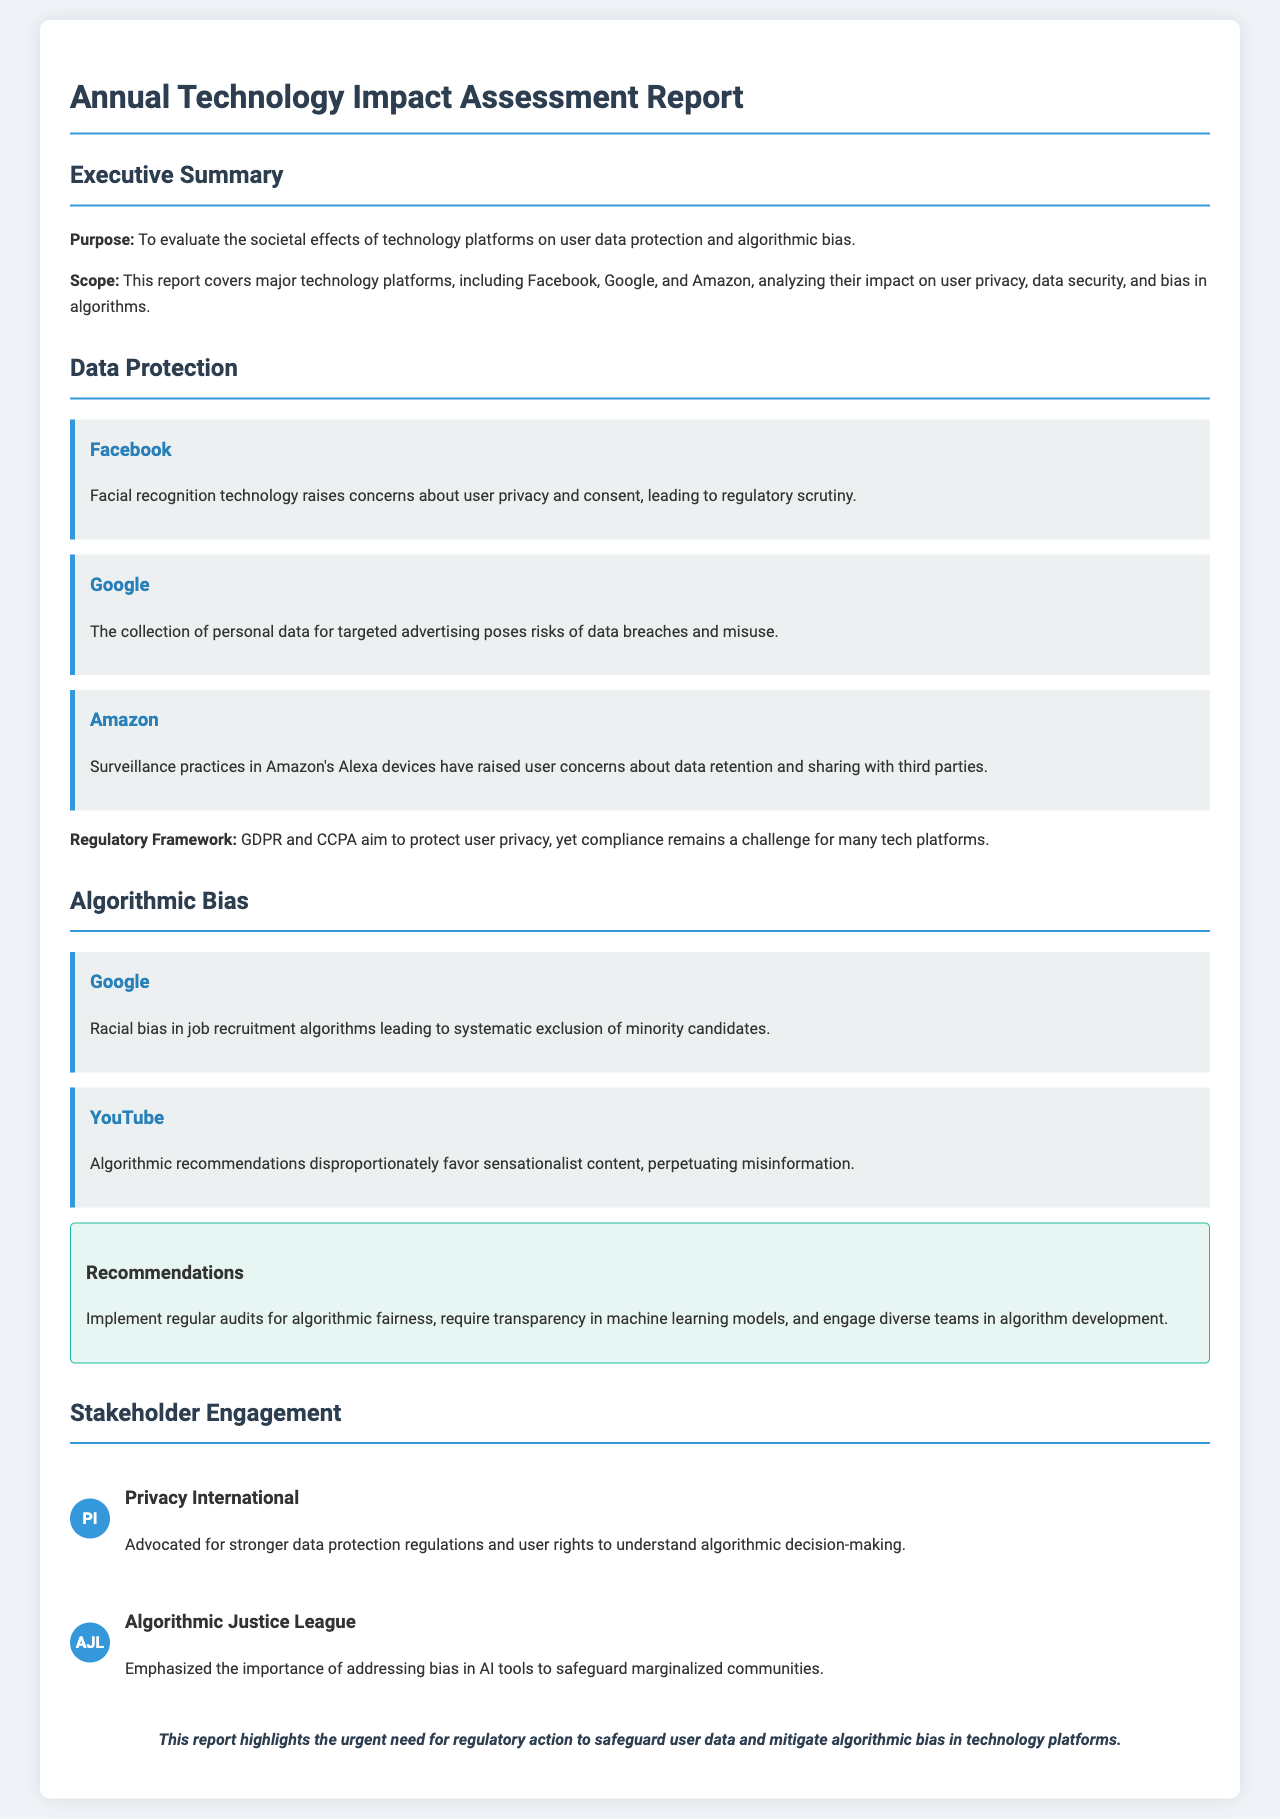What is the purpose of the report? The purpose of the report is to evaluate the societal effects of technology platforms on user data protection and algorithmic bias.
Answer: To evaluate the societal effects of technology platforms on user data protection and algorithmic bias Which platforms are analyzed in the report? The report covers major technology platforms, including Facebook, Google, and Amazon.
Answer: Facebook, Google, and Amazon What concerning technology does Facebook use? The report mentions that facial recognition technology raises concerns about user privacy and consent.
Answer: Facial recognition technology What type of bias is identified in Google's algorithms? The report highlights racial bias in job recruitment algorithms leading to systematic exclusion of minority candidates.
Answer: Racial bias What is one recommendation given in the report? The report recommends implementing regular audits for algorithmic fairness.
Answer: Implement regular audits for algorithmic fairness Who is Privacy International? Privacy International is an organization that advocated for stronger data protection regulations and user rights to understand algorithmic decision-making.
Answer: Advocated for stronger data protection regulations What is the regulatory framework mentioned in relation to data protection? GDPR and CCPA are mentioned as the regulatory frameworks aimed to protect user privacy.
Answer: GDPR and CCPA What issue is raised concerning YouTube’s algorithm? The report states that algorithmic recommendations disproportionately favor sensationalist content, perpetuating misinformation.
Answer: Favor sensationalist content What is emphasized by the Algorithmic Justice League? The Algorithmic Justice League emphasizes the importance of addressing bias in AI tools to safeguard marginalized communities.
Answer: Importance of addressing bias in AI tools 